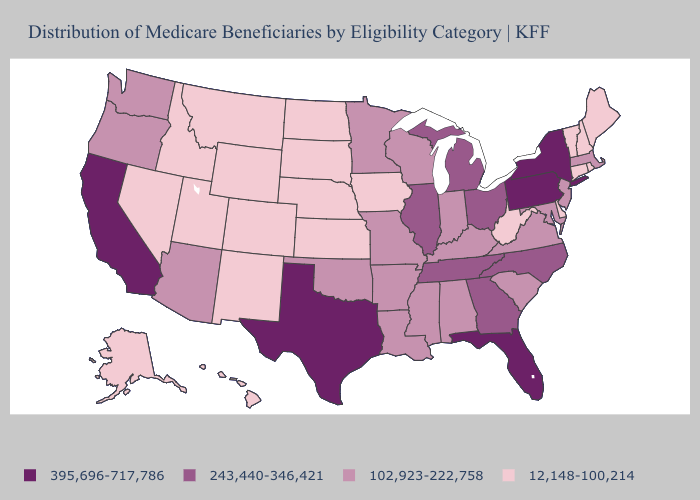Which states have the highest value in the USA?
Write a very short answer. California, Florida, New York, Pennsylvania, Texas. Does Michigan have the highest value in the USA?
Write a very short answer. No. Which states hav the highest value in the MidWest?
Give a very brief answer. Illinois, Michigan, Ohio. Which states have the lowest value in the West?
Quick response, please. Alaska, Colorado, Hawaii, Idaho, Montana, Nevada, New Mexico, Utah, Wyoming. What is the value of Minnesota?
Answer briefly. 102,923-222,758. What is the value of Alabama?
Write a very short answer. 102,923-222,758. Does North Carolina have the lowest value in the USA?
Keep it brief. No. Which states have the lowest value in the USA?
Give a very brief answer. Alaska, Colorado, Connecticut, Delaware, Hawaii, Idaho, Iowa, Kansas, Maine, Montana, Nebraska, Nevada, New Hampshire, New Mexico, North Dakota, Rhode Island, South Dakota, Utah, Vermont, West Virginia, Wyoming. What is the lowest value in the South?
Be succinct. 12,148-100,214. What is the highest value in the USA?
Quick response, please. 395,696-717,786. How many symbols are there in the legend?
Write a very short answer. 4. How many symbols are there in the legend?
Be succinct. 4. Name the states that have a value in the range 395,696-717,786?
Answer briefly. California, Florida, New York, Pennsylvania, Texas. Among the states that border Missouri , does Illinois have the highest value?
Write a very short answer. Yes. Among the states that border Rhode Island , does Connecticut have the lowest value?
Concise answer only. Yes. 